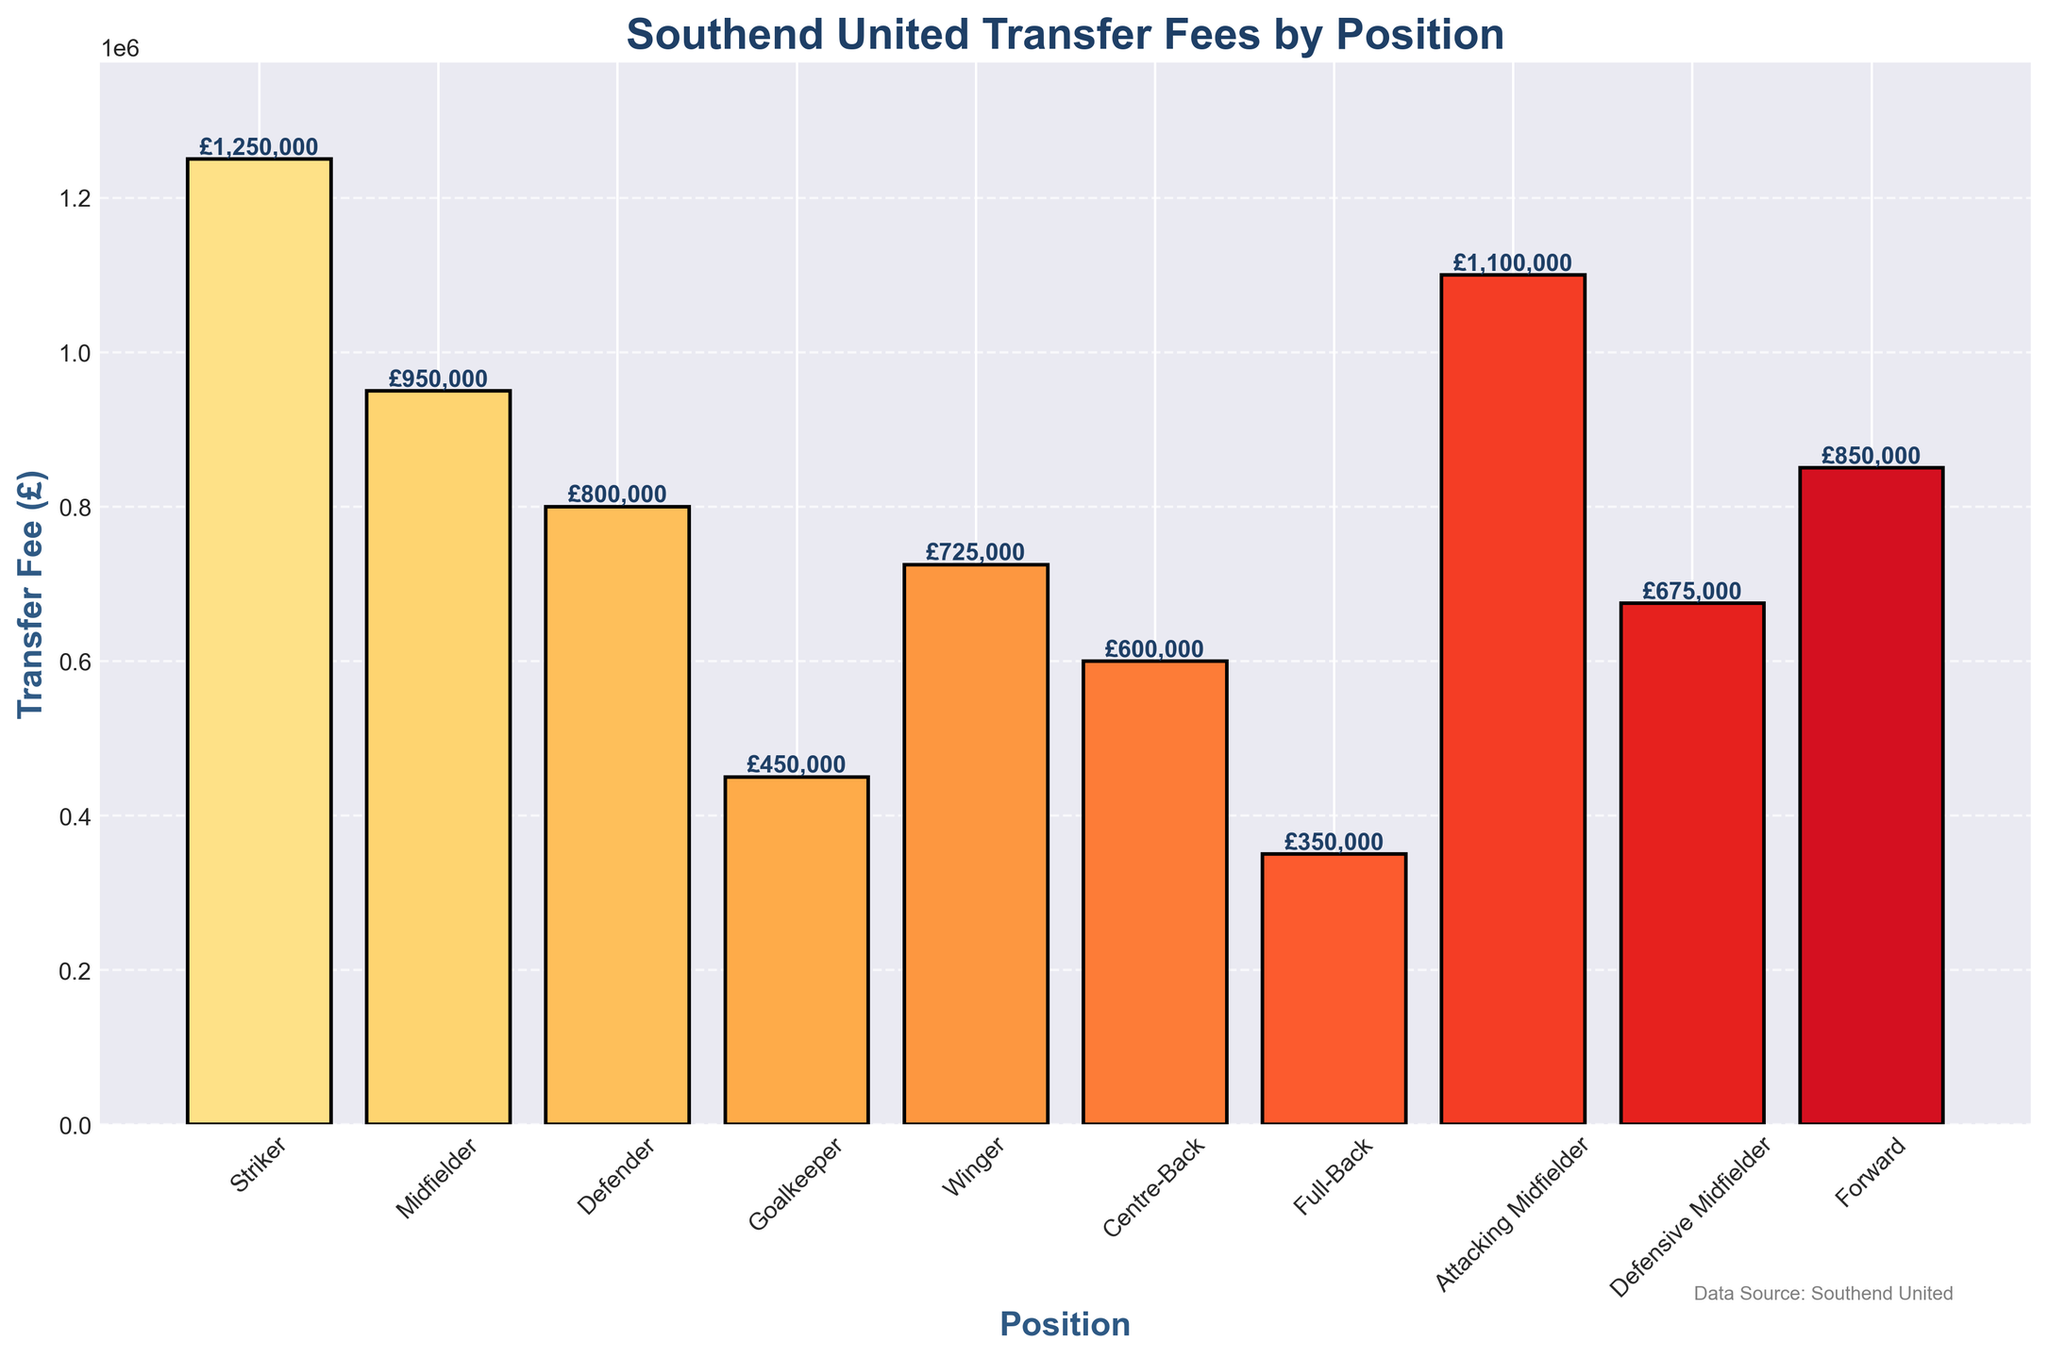what is the total transfer fee received for midfielders (including attacking and defensive midfielders)? To determine the total transfer fee for all types of midfielders, add the fees for Midfielder (£950,000), Attacking Midfielder (£1,100,000), and Defensive Midfielder (£675,000). So, £950,000 + £1,100,000 + £675,000 = £2,725,000
Answer: £2,725,000 Which position received the highest transfer fee, and what is that amount? The position with the highest bar in the plot represents the highest transfer fee. The Striker position received the highest transfer fee of £1,250,000
Answer: Striker, £1,250,000 Compared to Defenders, how much more was received for Wingers? The fee received for Defenders is £800,000, and for Wingers, it is £725,000. The difference is £725,000 - £800,000 = -£75,000. So, Wingers received £75,000 less than Defenders
Answer: £75,000 less What is the median transfer fee amount received across all positions? List all the transfer fees: £1,250,000, £950,000, £800,000, £450,000, £725,000, £600,000, £350,000, £1,100,000, £675,000, £850,000. Arrange them in ascending order: £350,000, £450,000, £600,000, £675,000, £725,000, £800,000, £850,000, £950,000, £1,100,000, £1,250,000. The median value (5th and 6th, averaged) is (£725,000 + £800,000) / 2 = £762,500
Answer: £762,500 Which position has the lowest transfer fee, and what is the amount? The position with the shortest bar on the plot has the lowest transfer fee. The Full-Back position has the lowest transfer fee of £350,000
Answer: Full-Back, £350,000 How much less is the transfer fee received for Goalkeepers compared to Strikers? The fee for Goalkeepers is £450,000, and for Strikers, it is £1,250,000. The difference is £1,250,000 - £450,000 = £800,000
Answer: £800,000 Are the fees for Forwards and Wingers more or less equal, and what's the exact difference? The transfer fee for Forwards is £850,000, while for Wingers, it is £725,000. The difference is £850,000 - £725,000 = £125,000, meaning they are not equal, with Forwards receiving more
Answer: £125,000 more If you sum the transfer fees for the defensive positions (Defender, Centre-Back, Full-Back), what is the total? The fees are: Defender (£800,000), Centre-Back (£600,000), and Full-Back (£350,000). The total is £800,000 + £600,000 + £350,000 = £1,750,000
Answer: £1,750,000 Which two positions have the closest transfer fees? By comparing the transfer fees, the Forward (£850,000) and Defender (£800,000) have the closest transfer fees, with a difference of £50,000
Answer: Forward and Defender, £50,000 